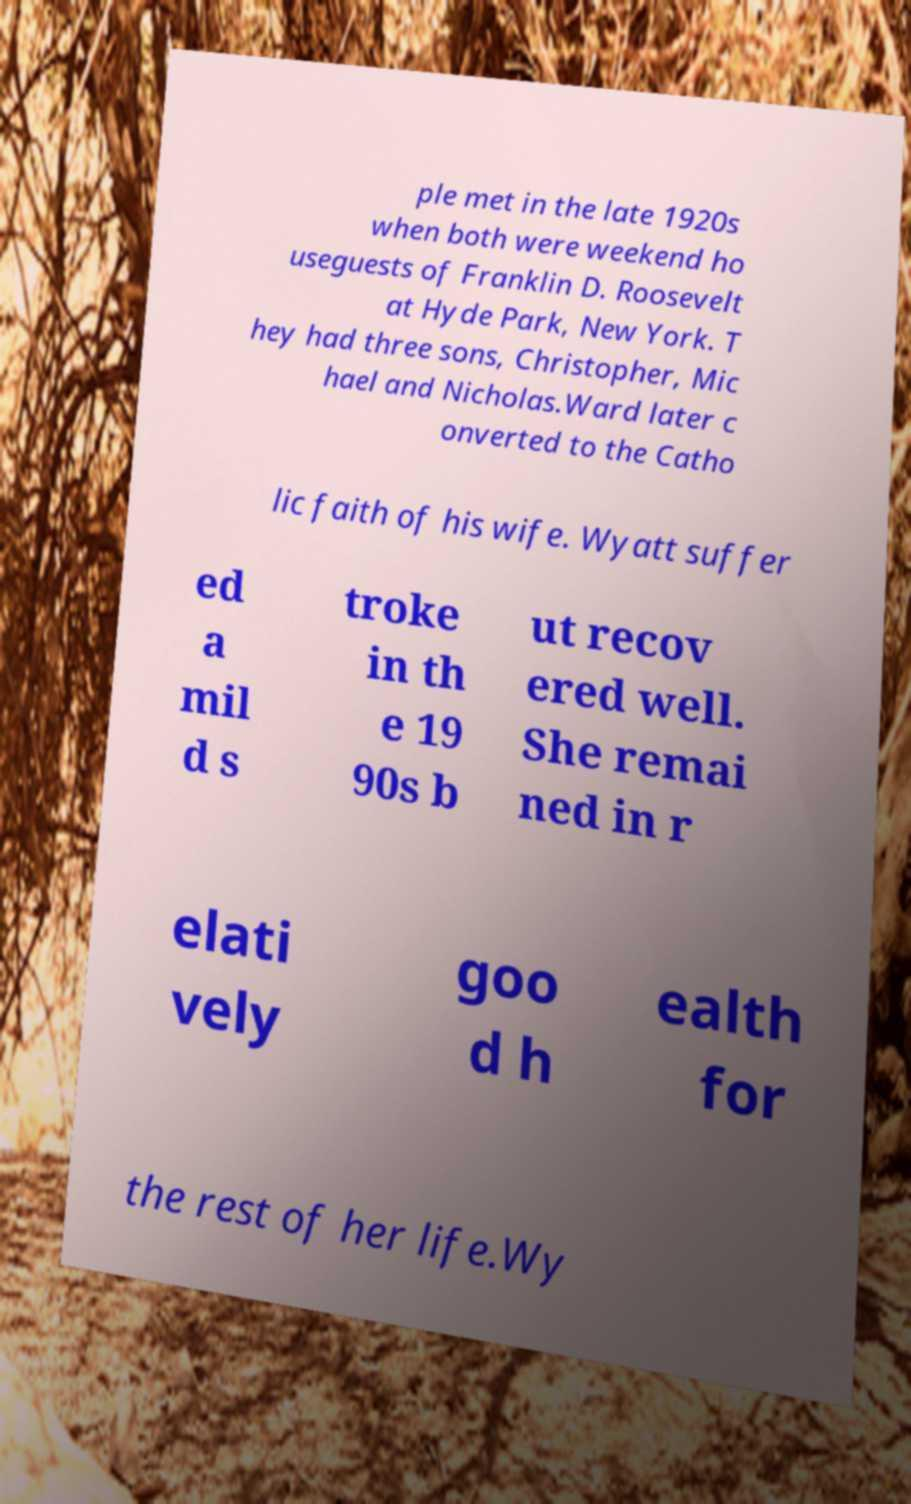Can you accurately transcribe the text from the provided image for me? ple met in the late 1920s when both were weekend ho useguests of Franklin D. Roosevelt at Hyde Park, New York. T hey had three sons, Christopher, Mic hael and Nicholas.Ward later c onverted to the Catho lic faith of his wife. Wyatt suffer ed a mil d s troke in th e 19 90s b ut recov ered well. She remai ned in r elati vely goo d h ealth for the rest of her life.Wy 